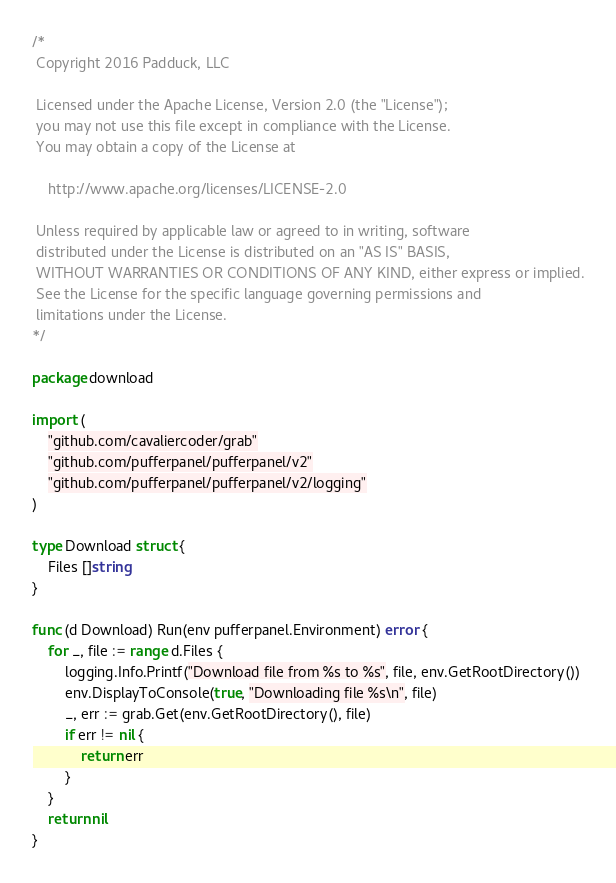Convert code to text. <code><loc_0><loc_0><loc_500><loc_500><_Go_>/*
 Copyright 2016 Padduck, LLC

 Licensed under the Apache License, Version 2.0 (the "License");
 you may not use this file except in compliance with the License.
 You may obtain a copy of the License at

 	http://www.apache.org/licenses/LICENSE-2.0

 Unless required by applicable law or agreed to in writing, software
 distributed under the License is distributed on an "AS IS" BASIS,
 WITHOUT WARRANTIES OR CONDITIONS OF ANY KIND, either express or implied.
 See the License for the specific language governing permissions and
 limitations under the License.
*/

package download

import (
	"github.com/cavaliercoder/grab"
	"github.com/pufferpanel/pufferpanel/v2"
	"github.com/pufferpanel/pufferpanel/v2/logging"
)

type Download struct {
	Files []string
}

func (d Download) Run(env pufferpanel.Environment) error {
	for _, file := range d.Files {
		logging.Info.Printf("Download file from %s to %s", file, env.GetRootDirectory())
		env.DisplayToConsole(true, "Downloading file %s\n", file)
		_, err := grab.Get(env.GetRootDirectory(), file)
		if err != nil {
			return err
		}
	}
	return nil
}
</code> 